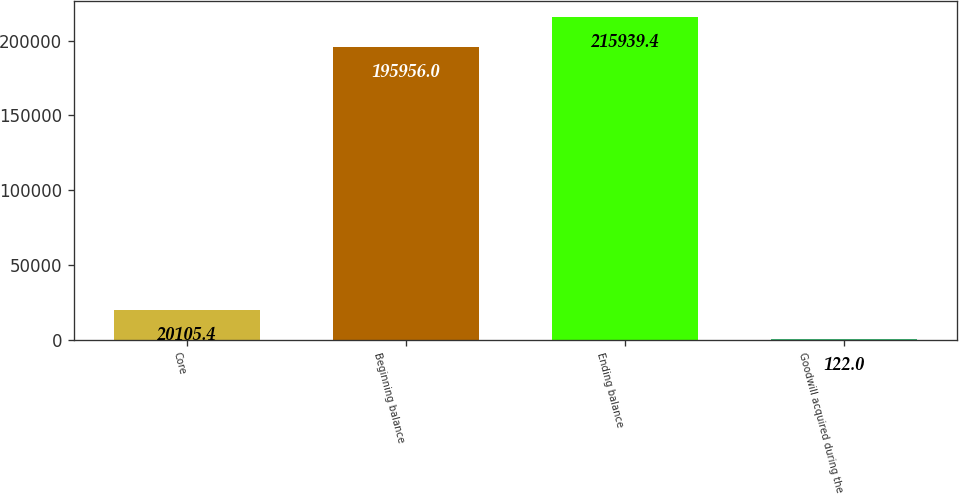<chart> <loc_0><loc_0><loc_500><loc_500><bar_chart><fcel>Core<fcel>Beginning balance<fcel>Ending balance<fcel>Goodwill acquired during the<nl><fcel>20105.4<fcel>195956<fcel>215939<fcel>122<nl></chart> 